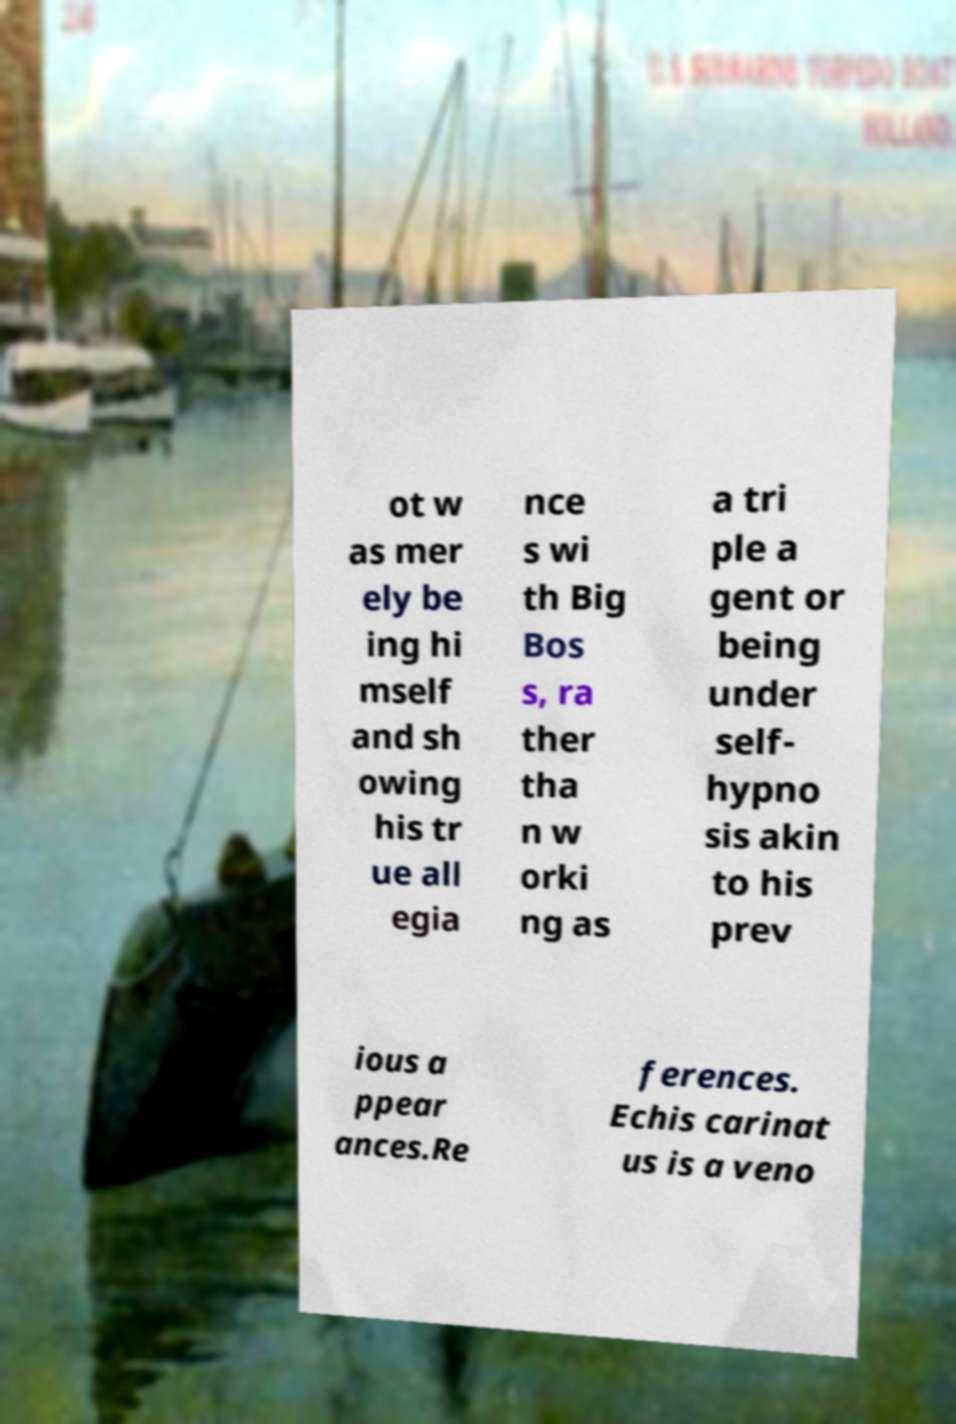For documentation purposes, I need the text within this image transcribed. Could you provide that? ot w as mer ely be ing hi mself and sh owing his tr ue all egia nce s wi th Big Bos s, ra ther tha n w orki ng as a tri ple a gent or being under self- hypno sis akin to his prev ious a ppear ances.Re ferences. Echis carinat us is a veno 